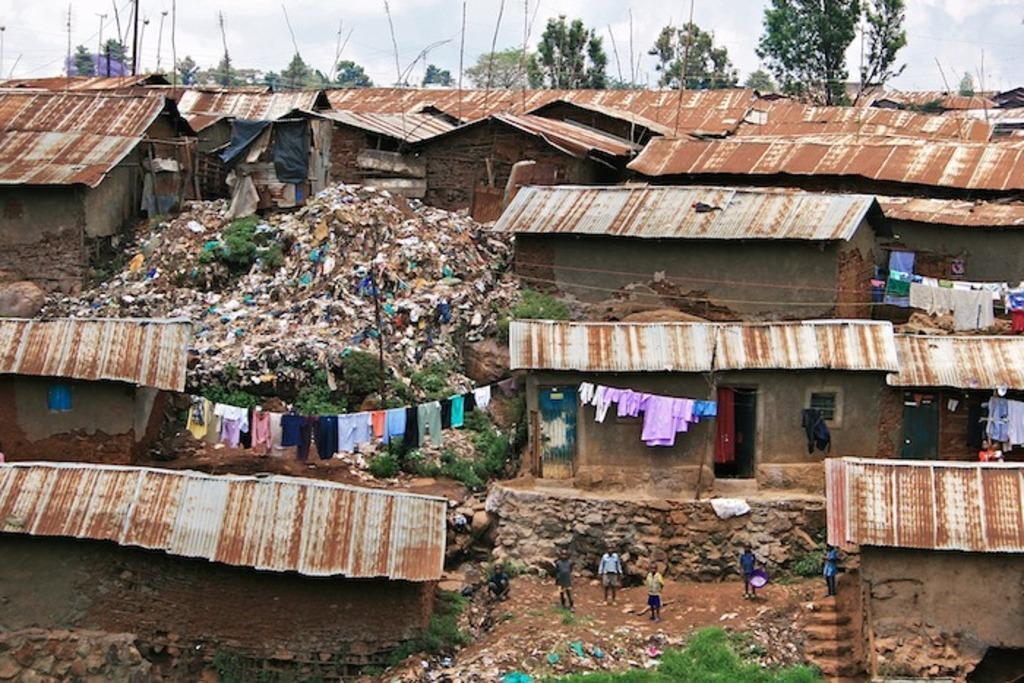In one or two sentences, can you explain what this image depicts? These are the houses with the roofs. I can see the clothes hanging to the rope. There are few people standing. This looks like a garbage. I can see the trees and plants. 